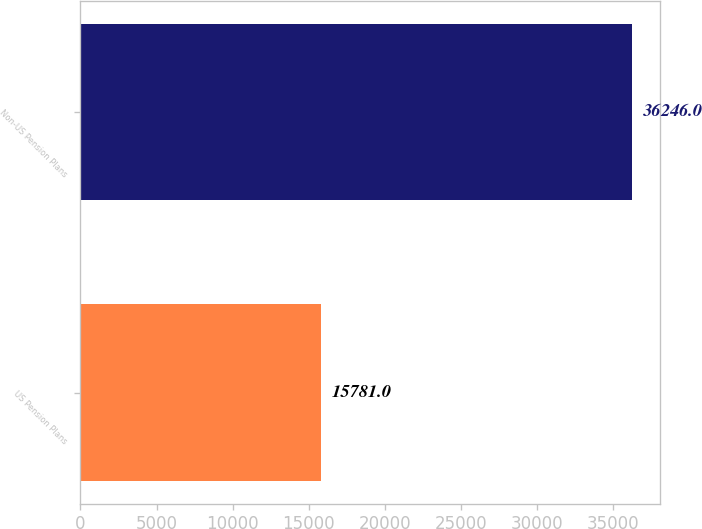Convert chart. <chart><loc_0><loc_0><loc_500><loc_500><bar_chart><fcel>US Pension Plans<fcel>Non-US Pension Plans<nl><fcel>15781<fcel>36246<nl></chart> 